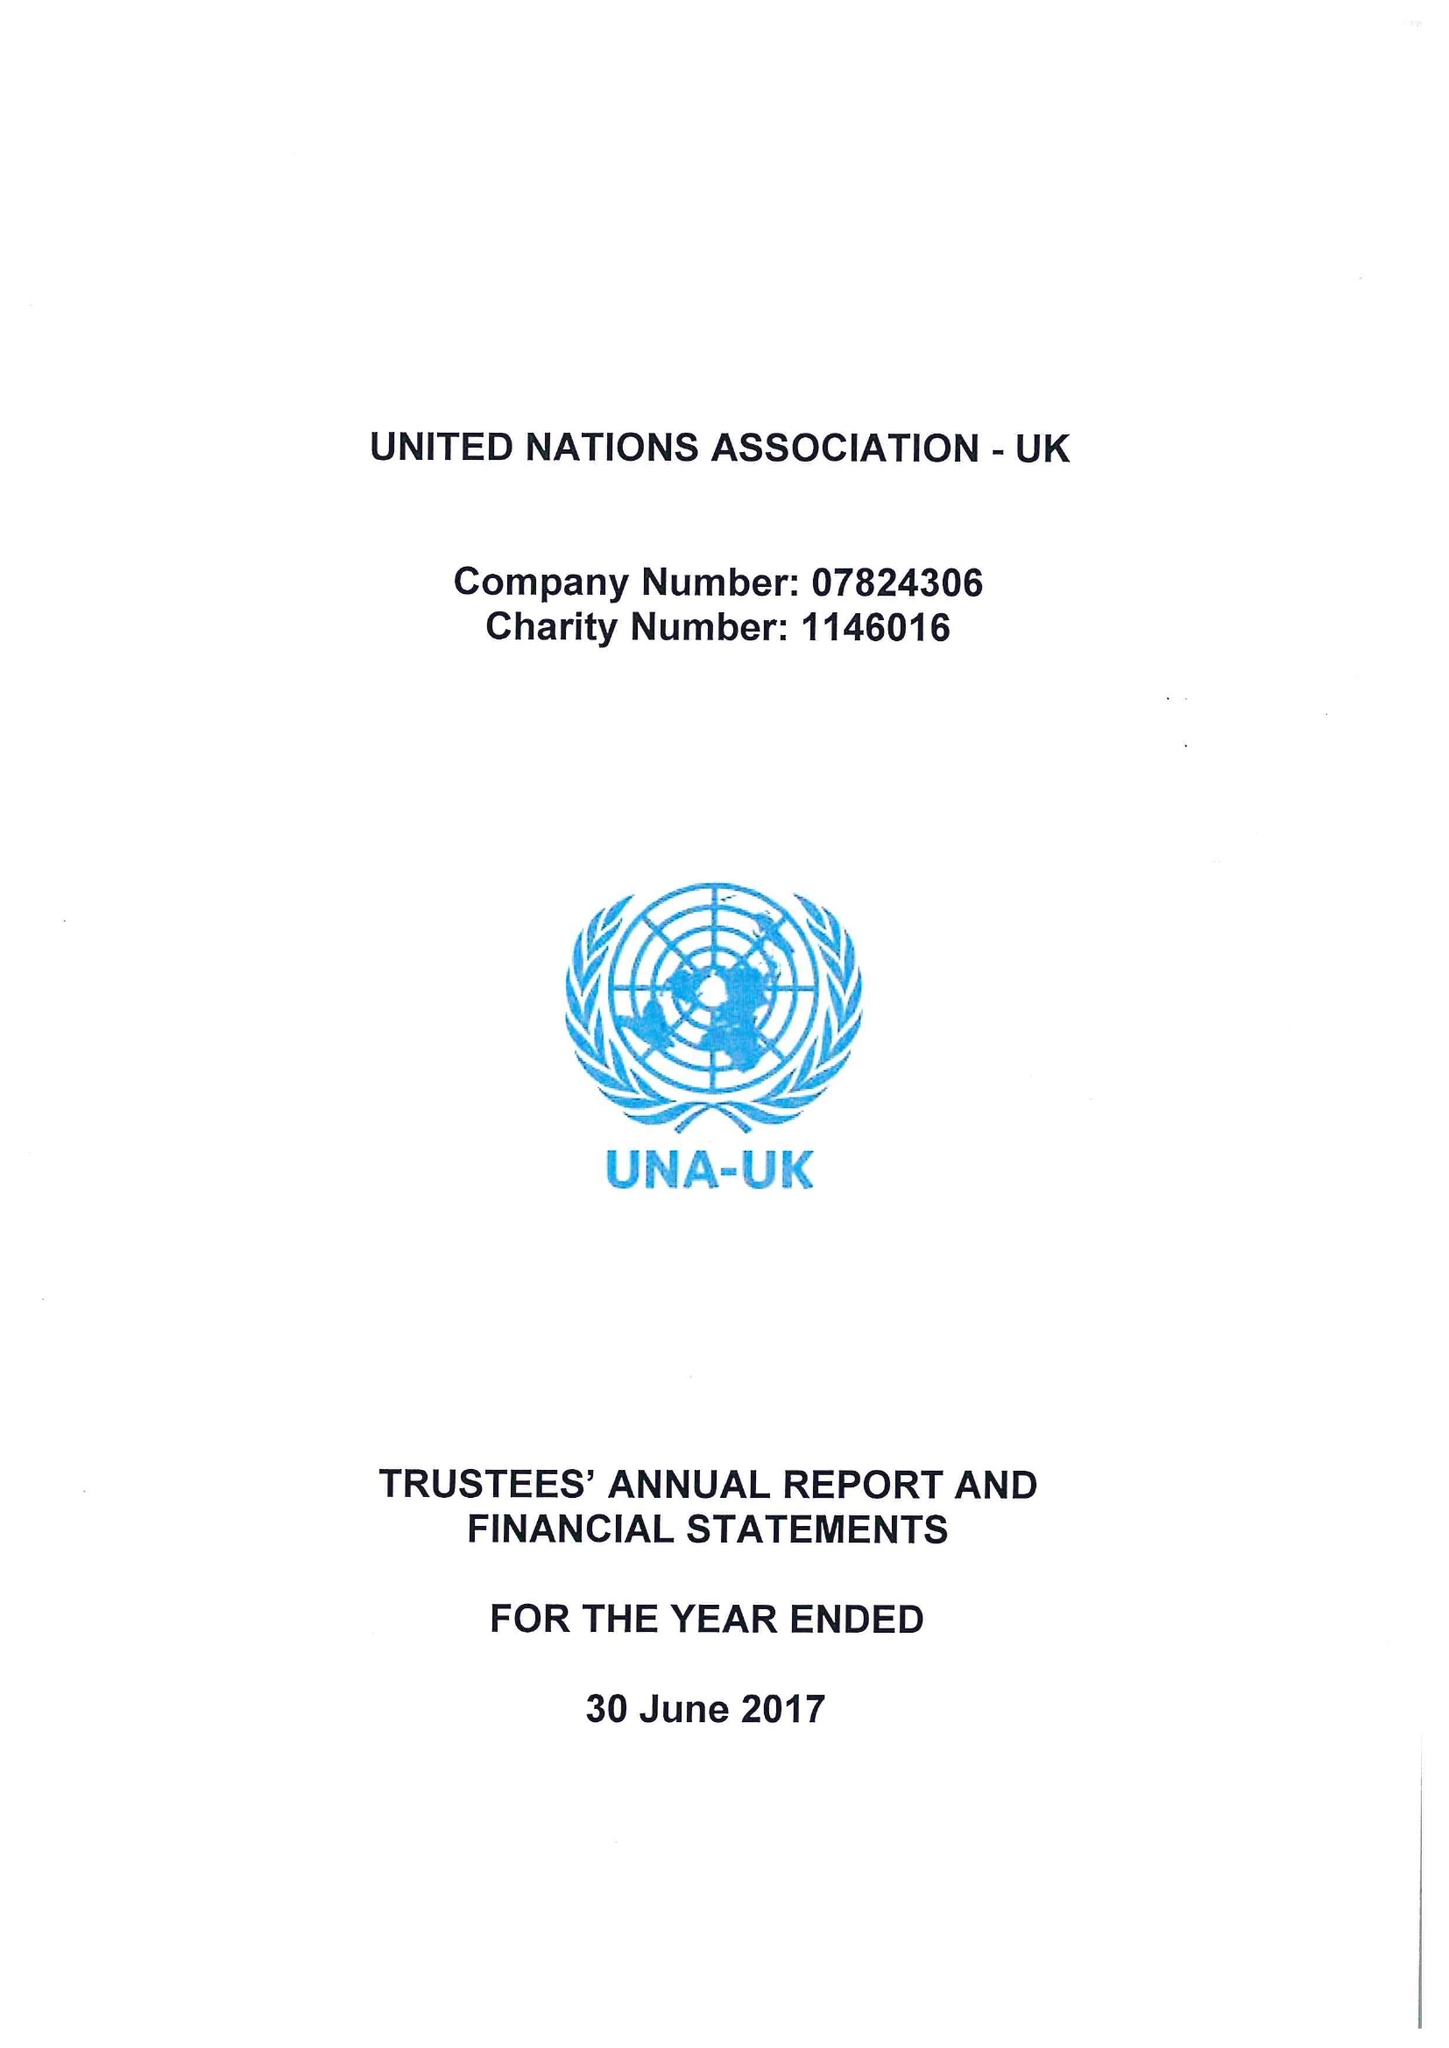What is the value for the address__post_town?
Answer the question using a single word or phrase. LONDON 